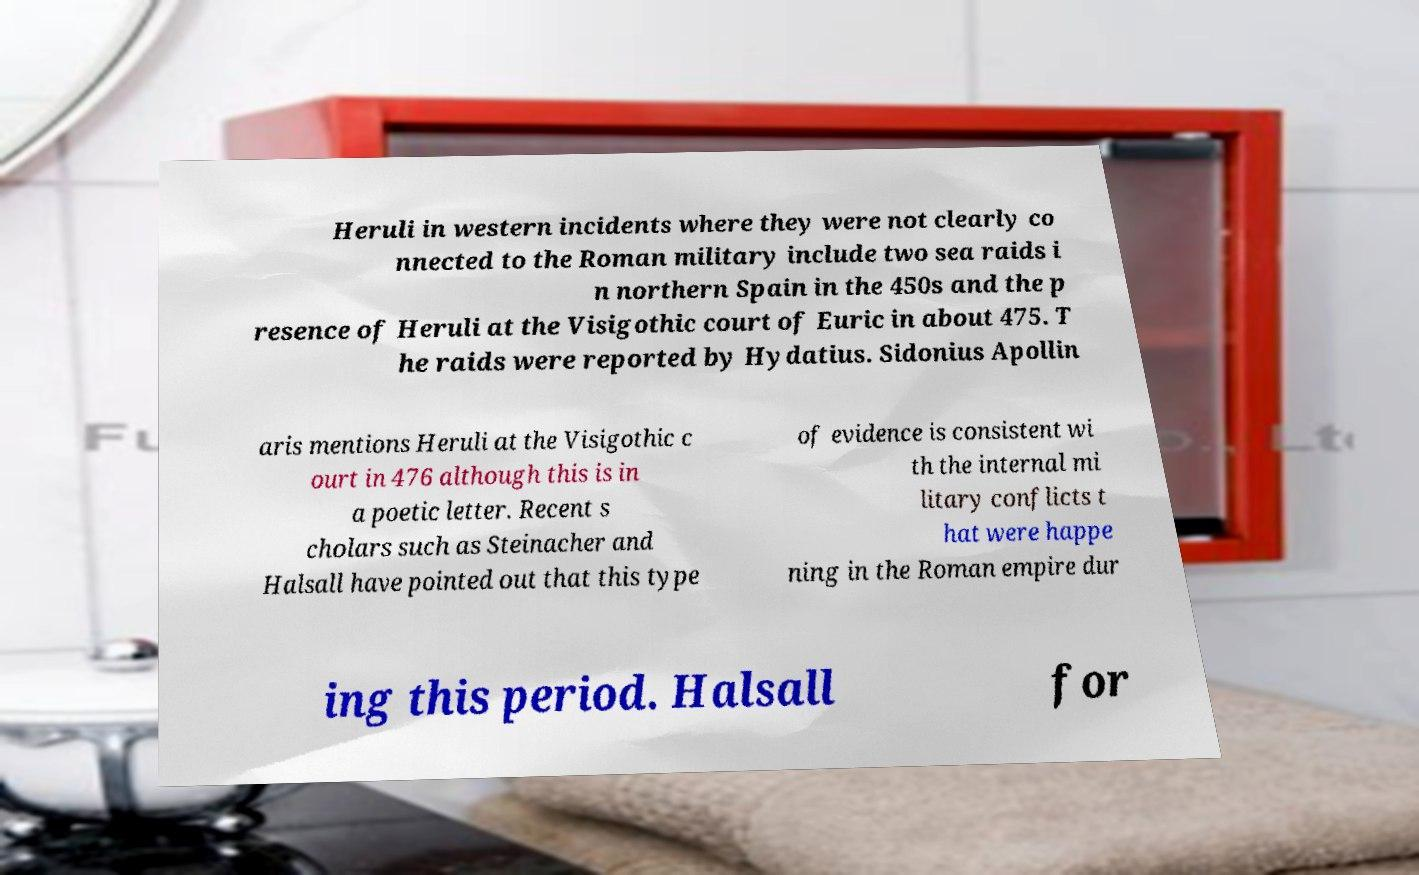Could you assist in decoding the text presented in this image and type it out clearly? Heruli in western incidents where they were not clearly co nnected to the Roman military include two sea raids i n northern Spain in the 450s and the p resence of Heruli at the Visigothic court of Euric in about 475. T he raids were reported by Hydatius. Sidonius Apollin aris mentions Heruli at the Visigothic c ourt in 476 although this is in a poetic letter. Recent s cholars such as Steinacher and Halsall have pointed out that this type of evidence is consistent wi th the internal mi litary conflicts t hat were happe ning in the Roman empire dur ing this period. Halsall for 